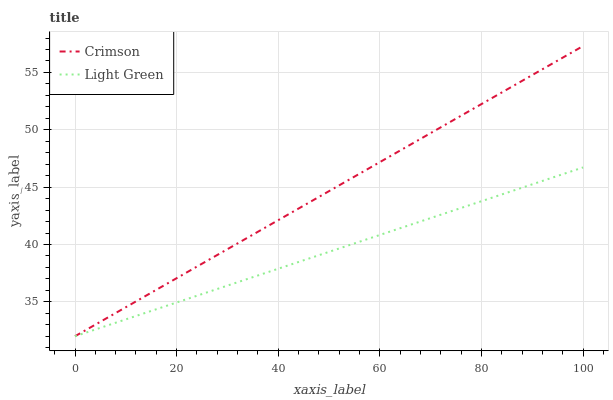Does Light Green have the minimum area under the curve?
Answer yes or no. Yes. Does Crimson have the maximum area under the curve?
Answer yes or no. Yes. Does Light Green have the maximum area under the curve?
Answer yes or no. No. Is Light Green the smoothest?
Answer yes or no. Yes. Is Crimson the roughest?
Answer yes or no. Yes. Is Light Green the roughest?
Answer yes or no. No. Does Crimson have the lowest value?
Answer yes or no. Yes. Does Crimson have the highest value?
Answer yes or no. Yes. Does Light Green have the highest value?
Answer yes or no. No. Does Light Green intersect Crimson?
Answer yes or no. Yes. Is Light Green less than Crimson?
Answer yes or no. No. Is Light Green greater than Crimson?
Answer yes or no. No. 